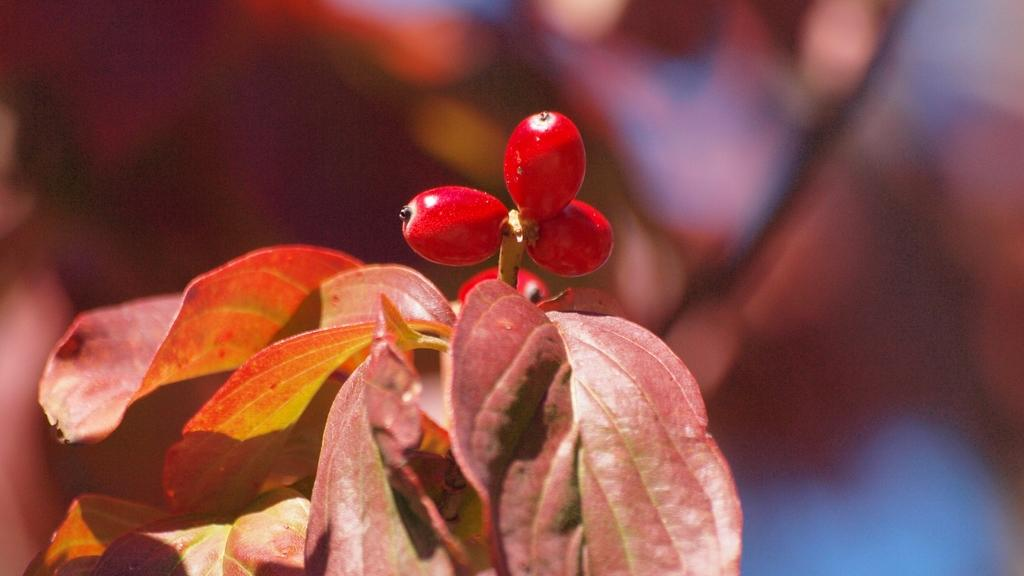What type of living organism is in the picture? There is a plant in the picture. What is the color of the plant? The plant has a reddish color. What can be seen on the plant besides its leaves? There are small fruits on the plant. What is the color of the fruits on the plant? The fruits have a red color. Can you see the veins on the wrist of the plant in the image? There is no wrist or veins present in the image, as it features a plant with fruits. 